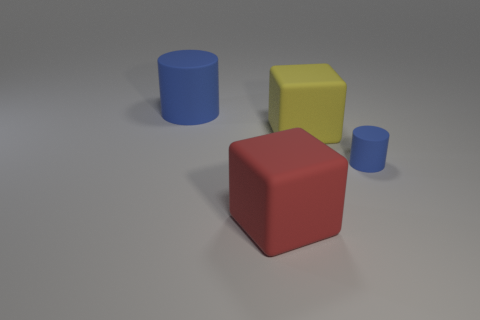Add 4 large cyan metal cubes. How many objects exist? 8 Subtract all big yellow shiny cubes. Subtract all big red cubes. How many objects are left? 3 Add 1 matte blocks. How many matte blocks are left? 3 Add 3 tiny blue things. How many tiny blue things exist? 4 Subtract 0 gray balls. How many objects are left? 4 